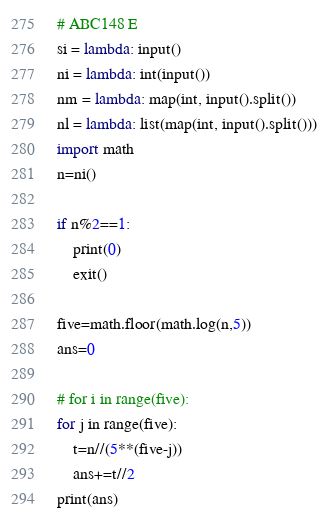<code> <loc_0><loc_0><loc_500><loc_500><_Python_># ABC148 E
si = lambda: input()
ni = lambda: int(input())
nm = lambda: map(int, input().split())
nl = lambda: list(map(int, input().split()))
import math
n=ni()

if n%2==1:
    print(0)
    exit()

five=math.floor(math.log(n,5))
ans=0

# for i in range(five):
for j in range(five):
    t=n//(5**(five-j))
    ans+=t//2
print(ans)
</code> 